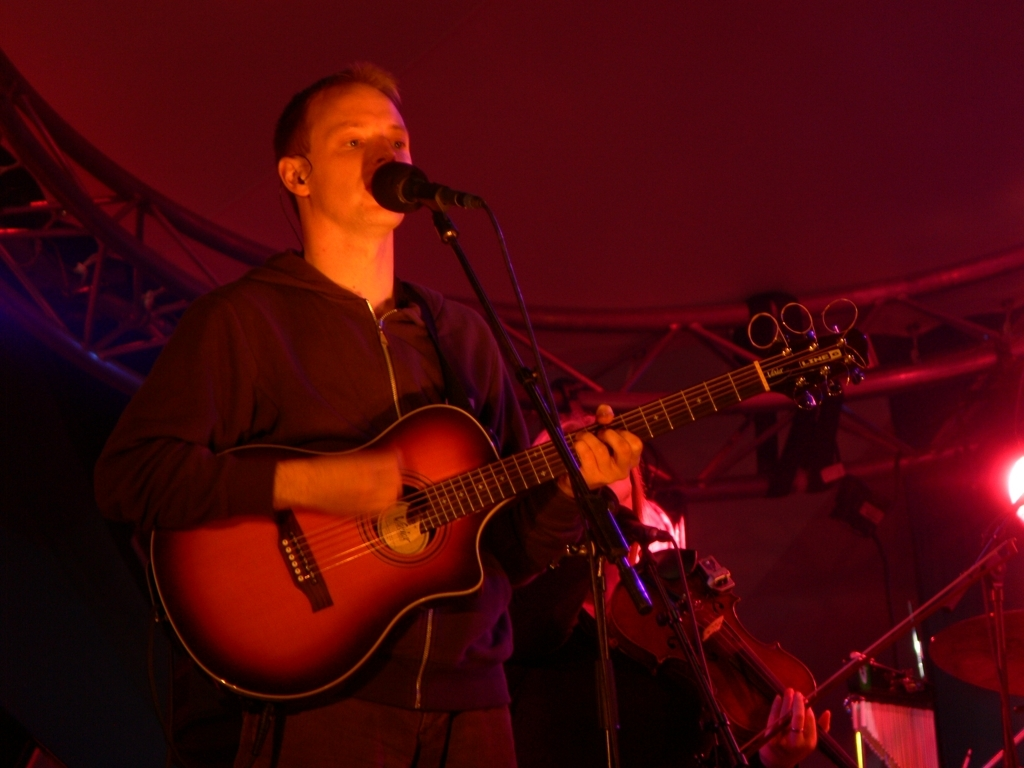How would you rate the overall quality of the image? A. outstanding B. moderate C. excellent D. poor Answer with the option's letter from the given choices directly. The image quality can be considered as moderate (Option B). Despite being well-composed with the musician engagingly captured mid-performance, the lighting conditions result in a grainy texture and lack of sharpness, making finer details difficult to discern. 